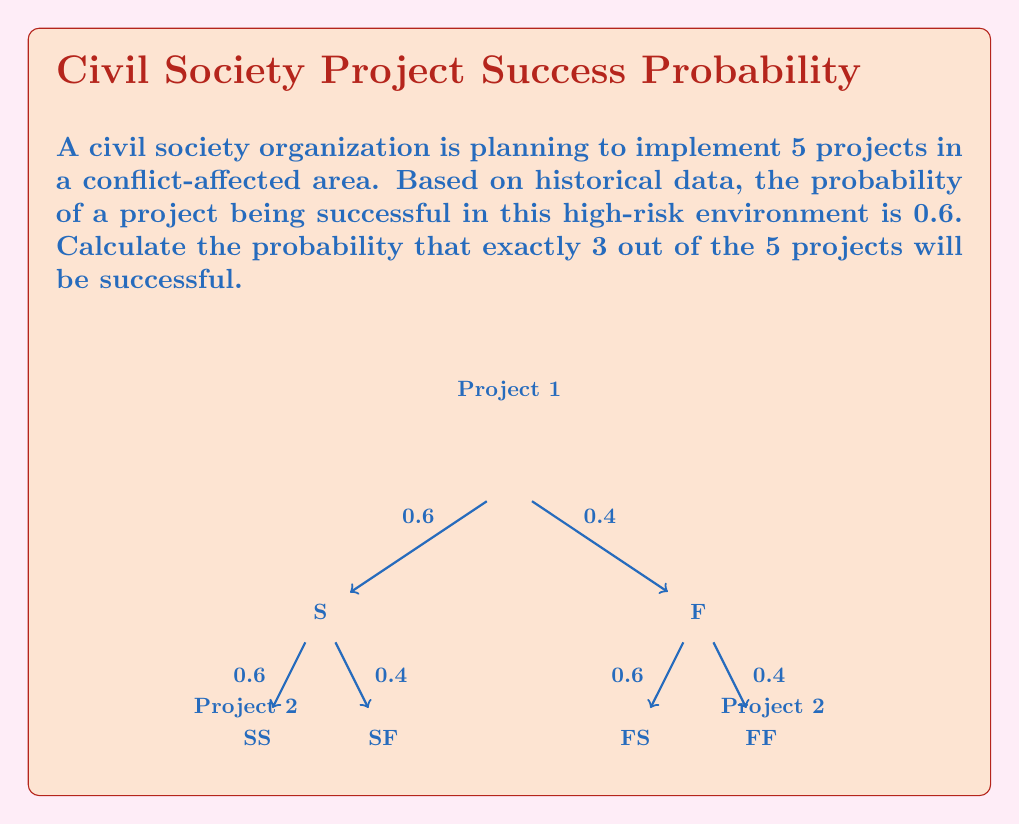What is the answer to this math problem? To solve this problem, we can use the binomial probability formula:

$$ P(X = k) = \binom{n}{k} p^k (1-p)^{n-k} $$

Where:
- $n$ is the number of trials (projects)
- $k$ is the number of successes we're interested in
- $p$ is the probability of success for each trial

Given:
- $n = 5$ (total number of projects)
- $k = 3$ (number of successful projects we're interested in)
- $p = 0.6$ (probability of success for each project)

Step 1: Calculate the binomial coefficient $\binom{n}{k}$
$$ \binom{5}{3} = \frac{5!}{3!(5-3)!} = \frac{5 \cdot 4}{2 \cdot 1} = 10 $$

Step 2: Calculate $p^k$
$$ 0.6^3 = 0.216 $$

Step 3: Calculate $(1-p)^{n-k}$
$$ (1-0.6)^{5-3} = 0.4^2 = 0.16 $$

Step 4: Multiply the results from steps 1, 2, and 3
$$ 10 \cdot 0.216 \cdot 0.16 = 0.3456 $$

Therefore, the probability of exactly 3 out of 5 projects being successful is 0.3456 or 34.56%.
Answer: $0.3456$ 